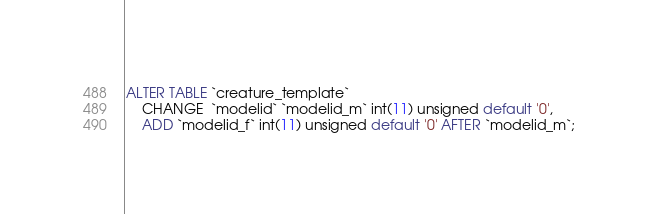<code> <loc_0><loc_0><loc_500><loc_500><_SQL_>ALTER TABLE `creature_template`
    CHANGE  `modelid` `modelid_m` int(11) unsigned default '0',
    ADD `modelid_f` int(11) unsigned default '0' AFTER `modelid_m`;
</code> 